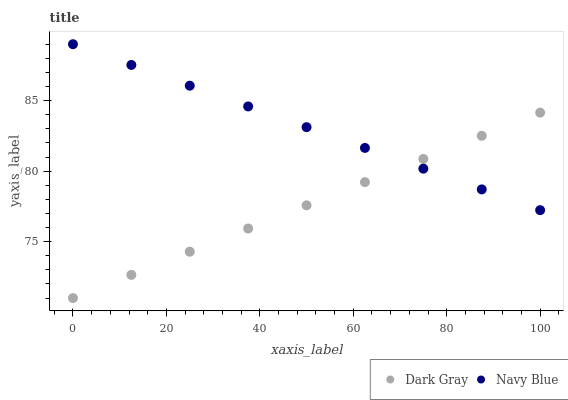Does Dark Gray have the minimum area under the curve?
Answer yes or no. Yes. Does Navy Blue have the maximum area under the curve?
Answer yes or no. Yes. Does Navy Blue have the minimum area under the curve?
Answer yes or no. No. Is Dark Gray the smoothest?
Answer yes or no. Yes. Is Navy Blue the roughest?
Answer yes or no. Yes. Is Navy Blue the smoothest?
Answer yes or no. No. Does Dark Gray have the lowest value?
Answer yes or no. Yes. Does Navy Blue have the lowest value?
Answer yes or no. No. Does Navy Blue have the highest value?
Answer yes or no. Yes. Does Dark Gray intersect Navy Blue?
Answer yes or no. Yes. Is Dark Gray less than Navy Blue?
Answer yes or no. No. Is Dark Gray greater than Navy Blue?
Answer yes or no. No. 